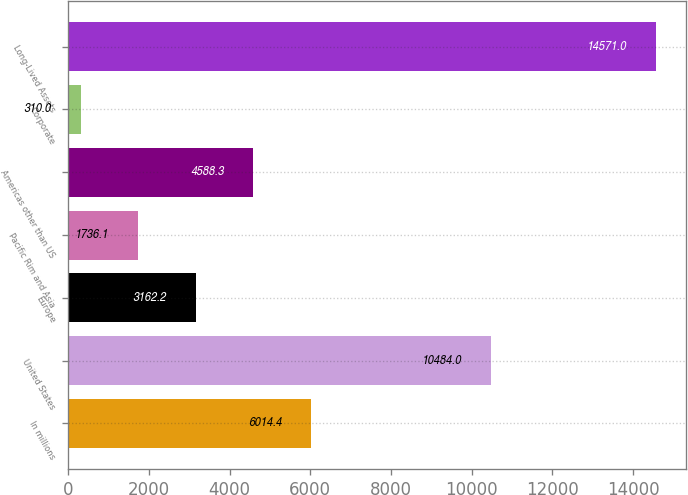<chart> <loc_0><loc_0><loc_500><loc_500><bar_chart><fcel>In millions<fcel>United States<fcel>Europe<fcel>Pacific Rim and Asia<fcel>Americas other than US<fcel>Corporate<fcel>Long-Lived Assets<nl><fcel>6014.4<fcel>10484<fcel>3162.2<fcel>1736.1<fcel>4588.3<fcel>310<fcel>14571<nl></chart> 